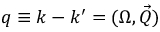Convert formula to latex. <formula><loc_0><loc_0><loc_500><loc_500>q \equiv k - k ^ { \prime } = ( \Omega , \vec { Q } )</formula> 